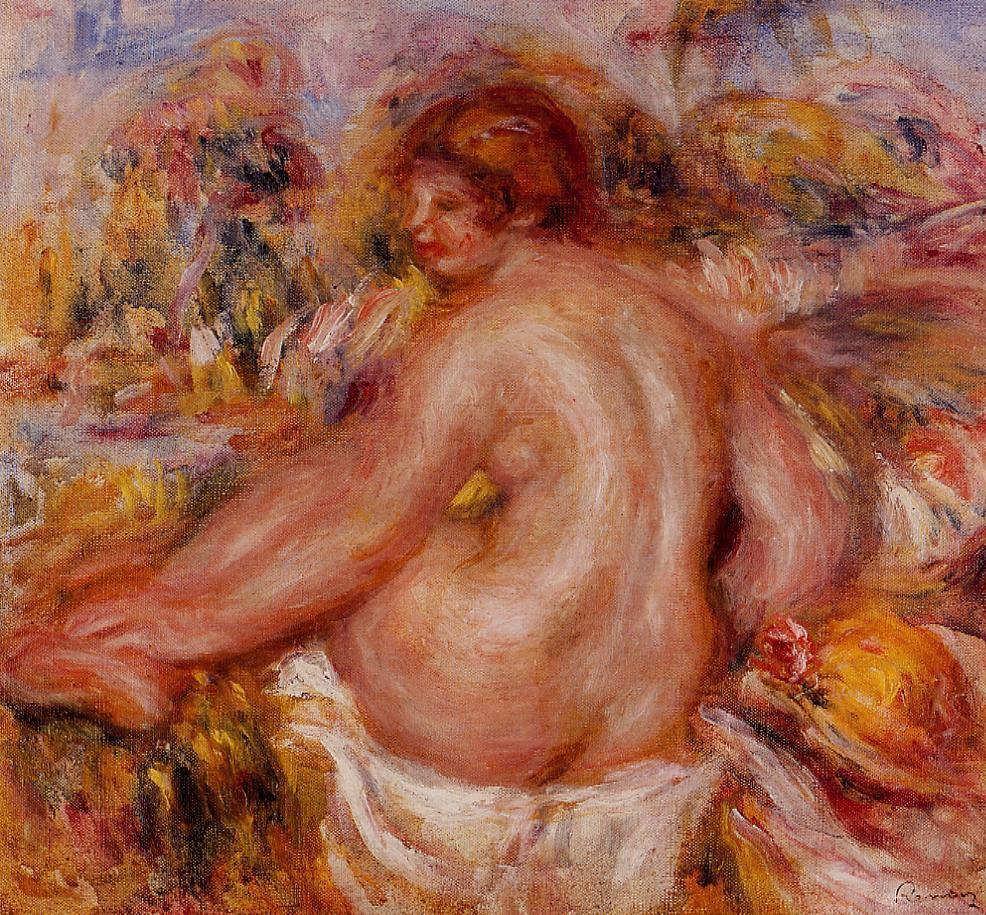What do you see happening in this image? The image is a mesmerizing impressionist painting by the celebrated French artist Pierre-Auguste Renoir. It features a nude woman with luscious, flowing red hair, gracefully seated amidst a vibrant and lush bed of flowers. The flowers are depicted in warm and inviting hues of pink, orange, and yellow, harmoniously blending with the woman's form to evoke feelings of tranquility and natural beauty.

In the painting's background, a soft blur of greens and blues subtly suggests a serene outdoor setting, with faint hints of structures and trees that add depth and contextual richness to the overall scene. The impressionist style of the painting is evident in its focus on capturing the fleeting effects of light and color, creating a dynamic yet soothing visual experience.

This particular painting is signed by Renoir in the lower right corner, lending an air of authenticity and historical significance. Renoir's masterful use of color, light, and form is on full display in this exquisite work, reflecting his significant contributions to the impressionist movement. 